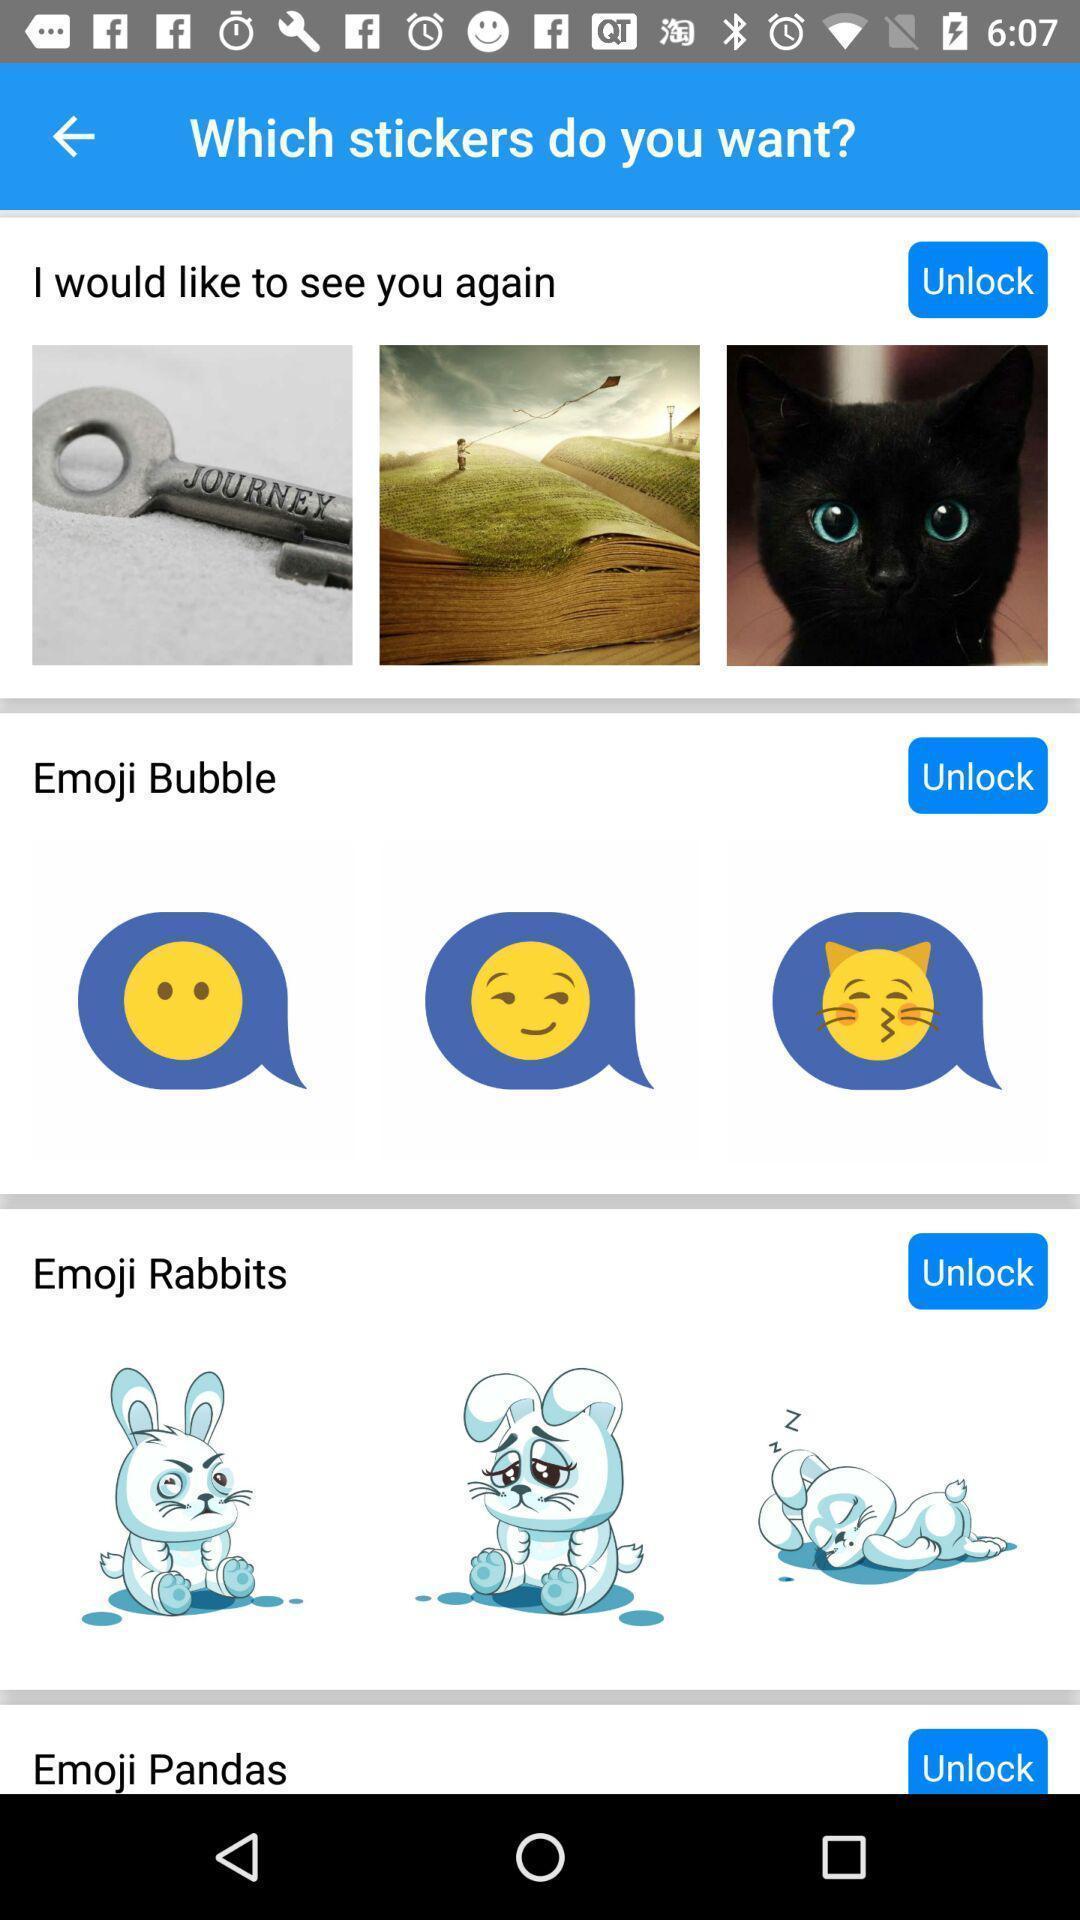What details can you identify in this image? Screen page of a stickers app. 